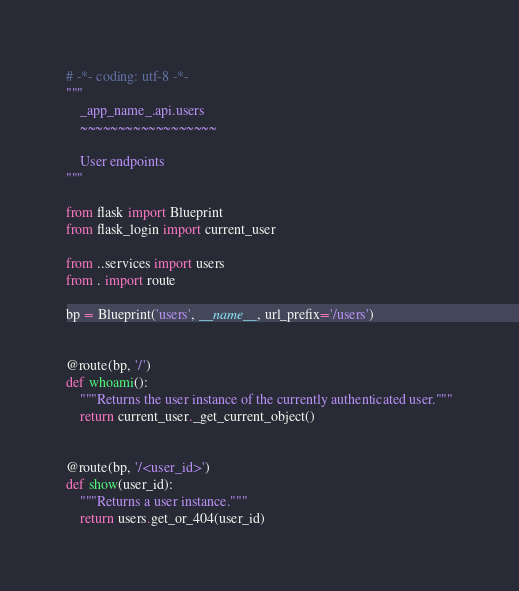Convert code to text. <code><loc_0><loc_0><loc_500><loc_500><_Python_># -*- coding: utf-8 -*-
"""
    _app_name_.api.users
    ~~~~~~~~~~~~~~~~~~

    User endpoints
"""

from flask import Blueprint
from flask_login import current_user

from ..services import users
from . import route

bp = Blueprint('users', __name__, url_prefix='/users')


@route(bp, '/')
def whoami():
    """Returns the user instance of the currently authenticated user."""
    return current_user._get_current_object()


@route(bp, '/<user_id>')
def show(user_id):
    """Returns a user instance."""
    return users.get_or_404(user_id)
</code> 